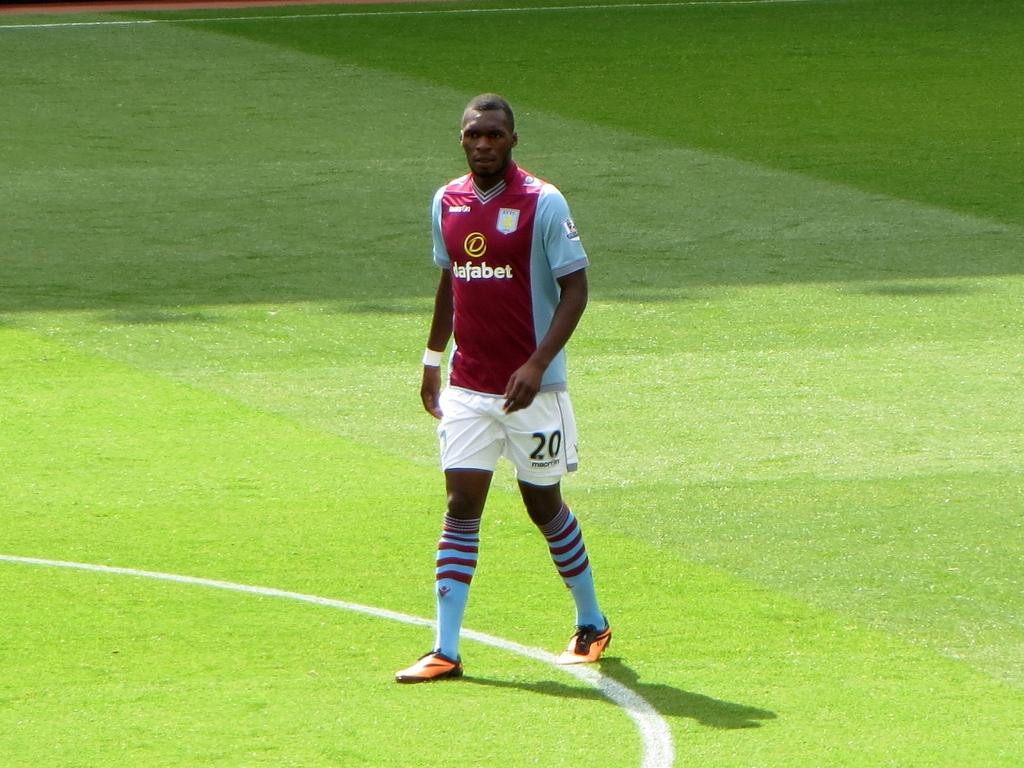<image>
Render a clear and concise summary of the photo. A man wears a dafabet shirt while standing on the field. 